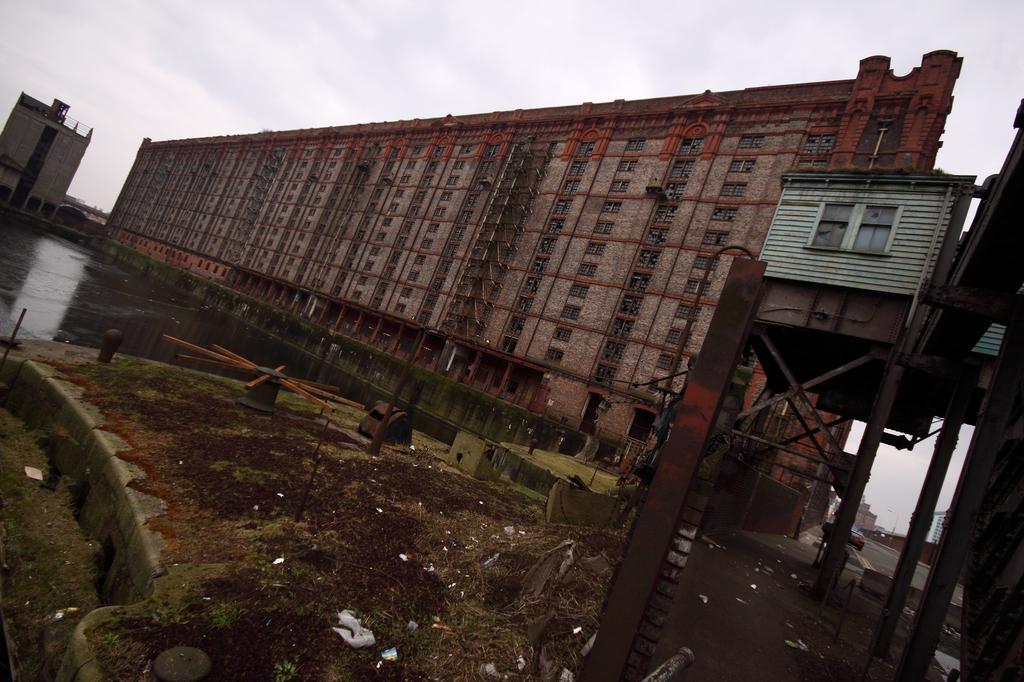How would you summarize this image in a sentence or two? In this image, we can see buildings, rods, wheels and some vehicles on the road. At the bottom, there is water and at the top, there is sky. 